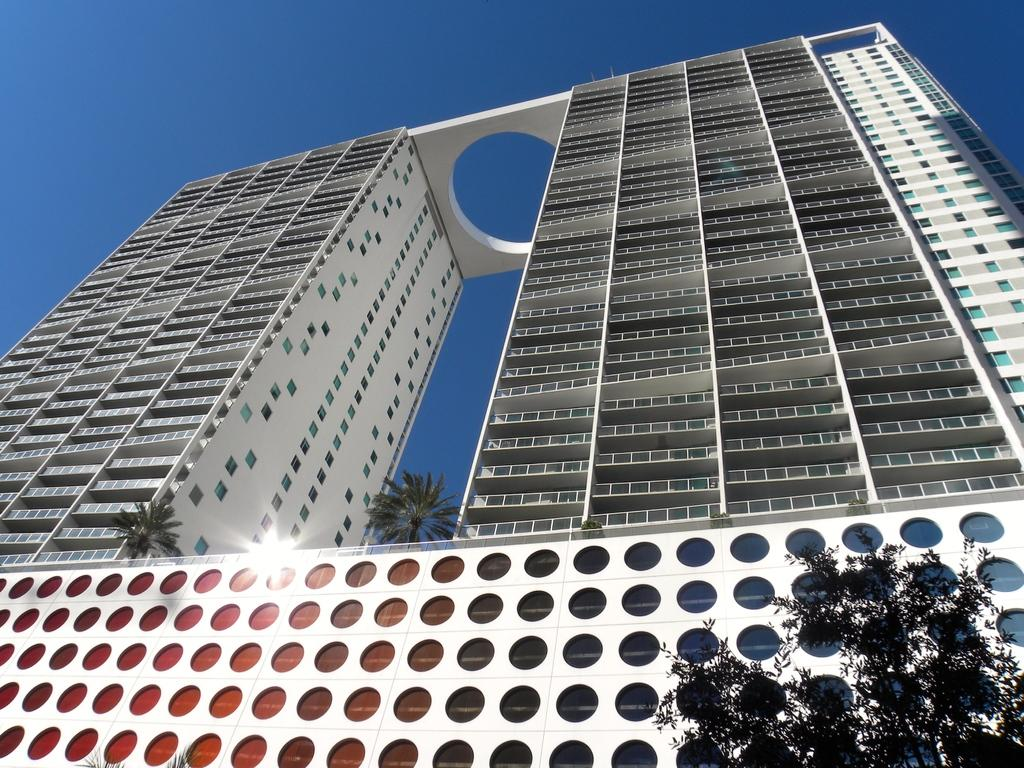What type of structure is present in the image? There is a building in the image. What other natural elements can be seen in the image? There are trees in the image. What can be seen in the distance in the image? The sky is visible in the background of the image. What holiday is being celebrated in the image? There is no indication of a holiday being celebrated in the image. Can you describe the discussion taking place between the trees in the image? There is no discussion taking place between the trees in the image, as trees do not engage in discussions. 